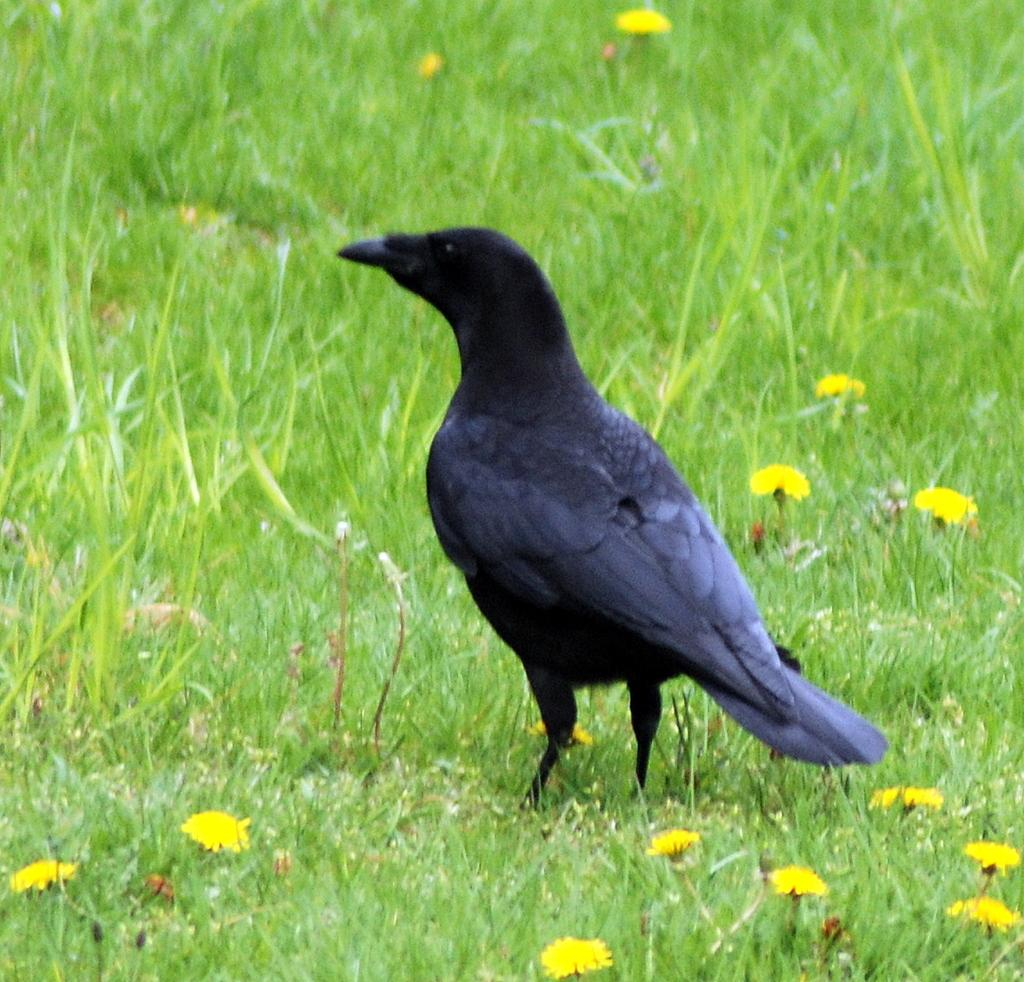What type of bird is in the image? There is a crow in the image. Where is the crow located in the image? The crow is standing on the ground. What type of flowers can be seen in the image? There are yellow color flowers in the image. What type of vegetation is present in the image? There is grass in the image. What type of party is happening in the image? There is no party happening in the image; it features a crow standing on the ground with yellow flowers and grass. What is the cause of the crow's presence in the image? The facts provided do not indicate the cause of the crow's presence in the image. 